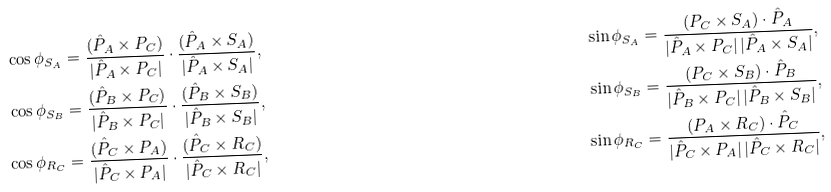<formula> <loc_0><loc_0><loc_500><loc_500>\cos \phi _ { S _ { A } } & = \frac { ( \hat { P } _ { A } \times { P } _ { C } ) } { | \hat { P } _ { A } \times { P } _ { C } | } \cdot \frac { ( \hat { P } _ { A } \times { S } _ { A } ) } { | \hat { P } _ { A } \times { S } _ { A } | } , & \sin \phi _ { S _ { A } } & = \frac { ( { P } _ { C } \times { S } _ { A } ) \cdot \hat { P } _ { A } } { | \hat { P } _ { A } \times { P } _ { C } | \, | \hat { P } _ { A } \times { S } _ { A } | } , \\ \cos \phi _ { S _ { B } } & = \frac { ( \hat { P } _ { B } \times { P } _ { C } ) } { | \hat { P } _ { B } \times { P } _ { C } | } \cdot \frac { ( \hat { P } _ { B } \times { S } _ { B } ) } { | \hat { P } _ { B } \times { S } _ { B } | } , & \sin \phi _ { S _ { B } } & = \frac { ( { P } _ { C } \times { S } _ { B } ) \cdot \hat { P } _ { B } } { | \hat { P } _ { B } \times { P } _ { C } | \, | \hat { P } _ { B } \times { S } _ { B } | } , \\ \cos \phi _ { R _ { C } } & = \frac { ( \hat { P } _ { C } \times { P } _ { A } ) } { | \hat { P } _ { C } \times { P } _ { A } | } \cdot \frac { ( \hat { P } _ { C } \times { R } _ { C } ) } { | \hat { P } _ { C } \times { R } _ { C } | } , & \sin \phi _ { R _ { C } } & = \frac { ( { P } _ { A } \times { R } _ { C } ) \cdot \hat { P } _ { C } } { | \hat { P } _ { C } \times { P } _ { A } | \, | \hat { P } _ { C } \times { R } _ { C } | } ,</formula> 